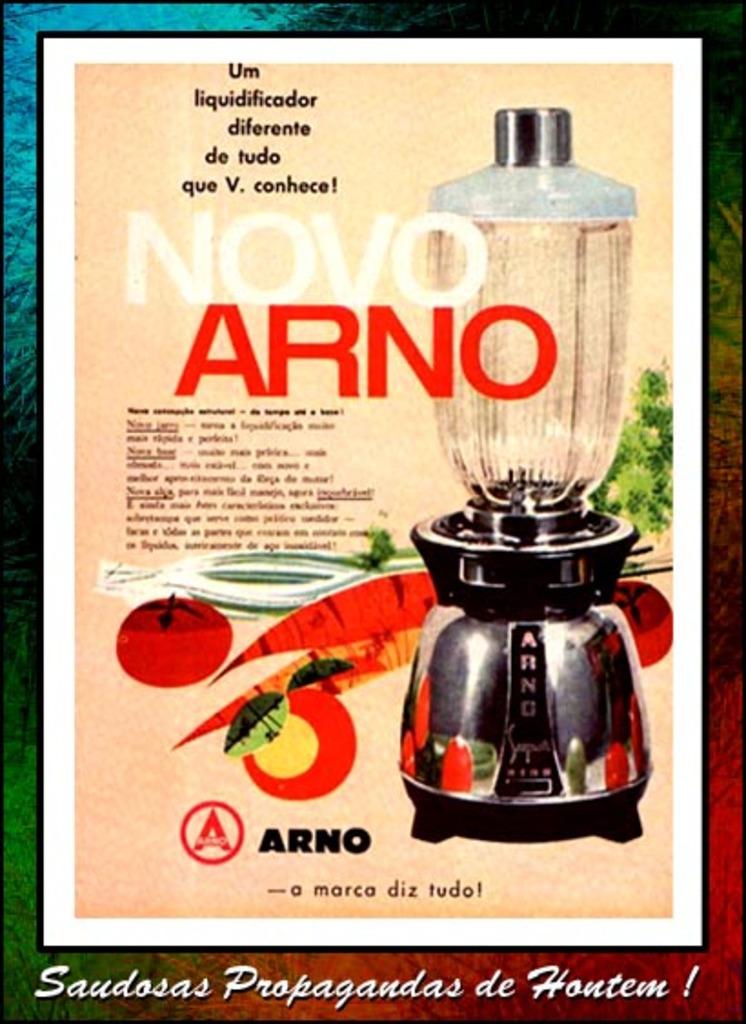What does it say in red after novo?
Your answer should be compact. Arno. What does it say in white before arno?
Your answer should be compact. Novo. 